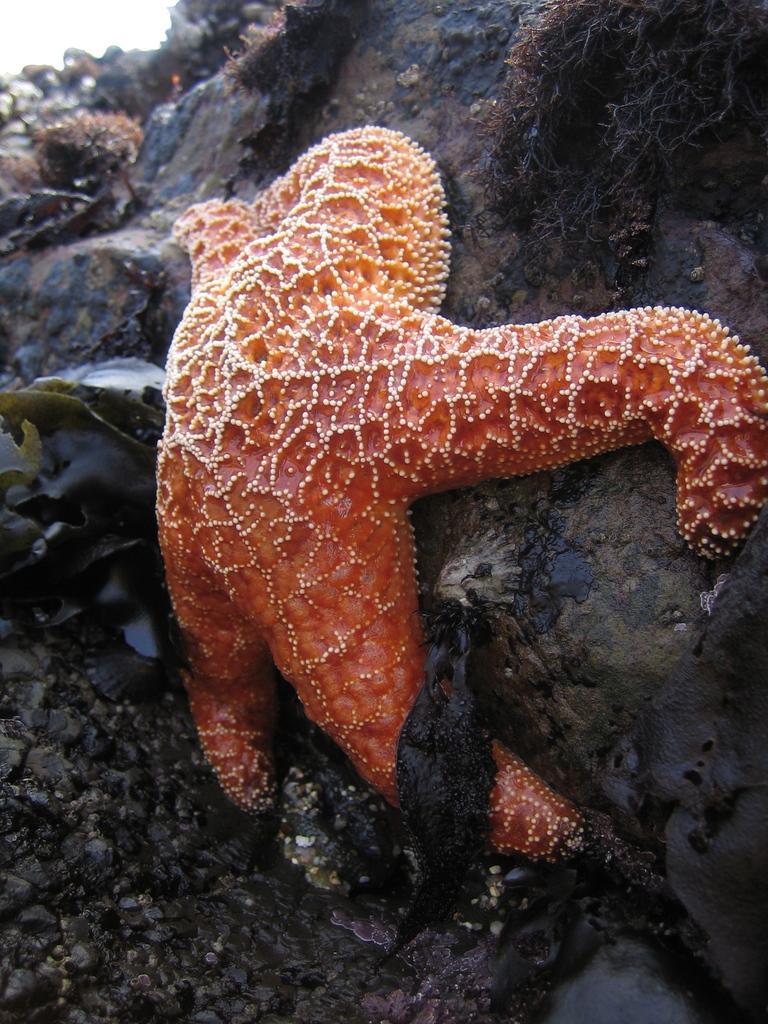How would you summarize this image in a sentence or two? In the center of this picture we can see an orange color starfish and we can see some other objects. 